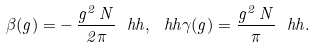Convert formula to latex. <formula><loc_0><loc_0><loc_500><loc_500>\beta ( g ) = - \, \frac { g ^ { 2 } \, N } { 2 \pi } \ h h , \ h h \gamma ( g ) = \frac { g ^ { 2 } \, N } { \pi } \ h h .</formula> 